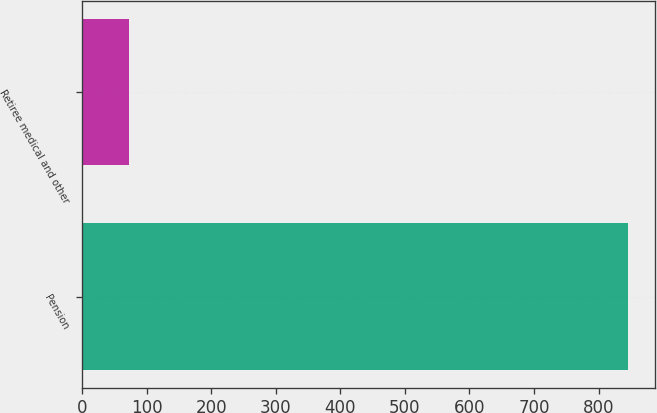<chart> <loc_0><loc_0><loc_500><loc_500><bar_chart><fcel>Pension<fcel>Retiree medical and other<nl><fcel>845<fcel>73<nl></chart> 